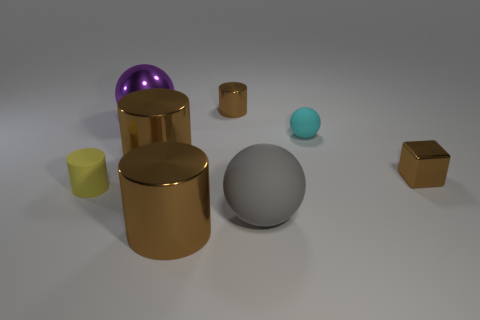What shape is the tiny thing that is the same color as the tiny metal block?
Ensure brevity in your answer.  Cylinder. There is a shiny cube that is the same color as the small metal cylinder; what size is it?
Your answer should be very brief. Small. Is the shape of the cyan thing the same as the gray thing?
Your response must be concise. Yes. How many objects are brown cylinders behind the block or small brown cylinders?
Your answer should be compact. 2. Are there the same number of big shiny objects that are behind the yellow matte thing and large brown cylinders on the right side of the gray ball?
Provide a short and direct response. No. How many other things are there of the same shape as the large gray thing?
Provide a succinct answer. 2. There is a matte thing that is in front of the tiny yellow thing; is it the same size as the sphere that is behind the tiny cyan sphere?
Keep it short and to the point. Yes. How many cubes are rubber objects or tiny yellow objects?
Make the answer very short. 0. How many rubber things are large purple spheres or brown things?
Your response must be concise. 0. What size is the purple object that is the same shape as the cyan object?
Keep it short and to the point. Large. 